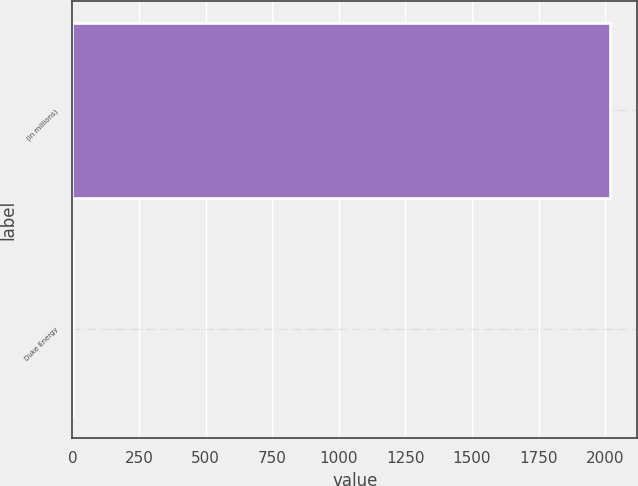Convert chart. <chart><loc_0><loc_0><loc_500><loc_500><bar_chart><fcel>(in millions)<fcel>Duke Energy<nl><fcel>2019<fcel>2<nl></chart> 